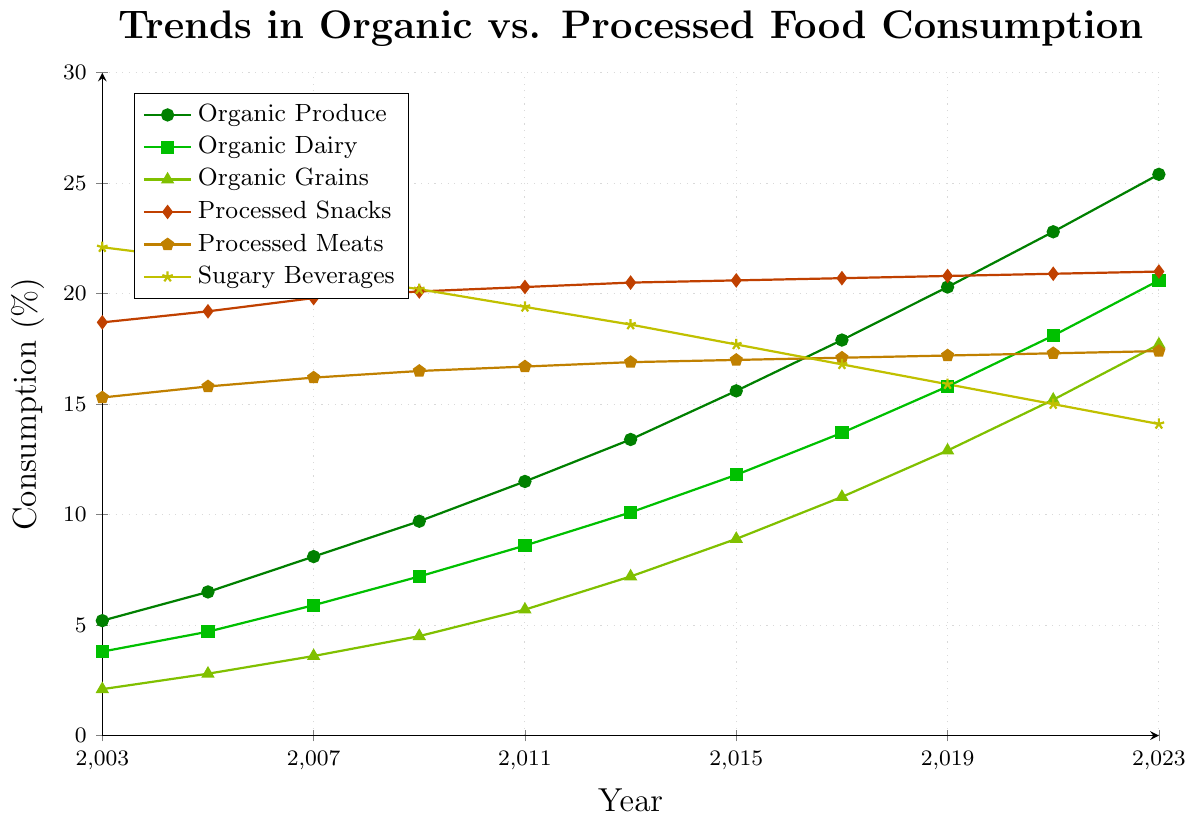Which food category showed the most significant increase in consumption over the 20-year period? To find the food category with the most significant increase, look at the consumption values in 2003 and 2023 for each category. Subtract the 2003 values from the 2023 values and identify the largest difference.
Answer: Organic Produce What is the approximate overall trend between organic and processed food consumption over the past 20 years? Visually compare the slopes of the lines representing organic (green lines) and processed foods (red/yellow lines). Organic food lines trend upward while processed food lines are relatively stable or downward.
Answer: Organic consumption is increasing, while processed food consumption is stable or decreasing By how much did the consumption of Sugary Beverages decrease from 2003 to 2023? Find the consumption values of Sugary Beverages in 2003 (22.1%) and 2023 (14.1%). Subtract the latter from the former to get the decrease.
Answer: 8.0% Which food type had the highest consumption in 2013? Look at the data point values for all food types in 2013 and identify the highest value.
Answer: Sugary Beverages What is the average consumption of Organic Dairy from 2003 to 2023? Sum all the yearly values for Organic Dairy from 2003 to 2023 and then divide by the number of years (11).
Answer: 11.18% Compare the growth rates between Organic Produce and Processed Snacks from 2003 to 2023. Calculate the difference between 2023 and 2003 values for both categories, then compare these differences.
Answer: Organic Produce grew by 20.2%, Processed Snacks grew by 2.3% Which processed food has the highest consumption in the year 2021? Look at the 2021 values for Processed Snacks, Processed Meats, and Sugary Beverages, and identify the highest value.
Answer: Processed Snacks Between 2003 and 2023, which year saw the highest increase in Organic Grains consumption compared to the previous year? Calculate the yearly differences for Organic Grains and identify the year with the highest difference.
Answer: 2011 How do the trends in Organic Dairy and Organic Grains compare over the past two decades? Visually examine the slopes and directions of the lines representing Organic Dairy and Organic Grains. Both lines are increasing, but Organic Dairy shows a steeper increase.
Answer: Both are increasing, but Organic Dairy is growing faster What is the sum of the consumption values of all food types in the year 2019? Add the consumption values for all six food types in the year 2019. (20.3 + 15.8 + 12.9 + 20.8 + 17.2 + 15.9)
Answer: 103.0% 